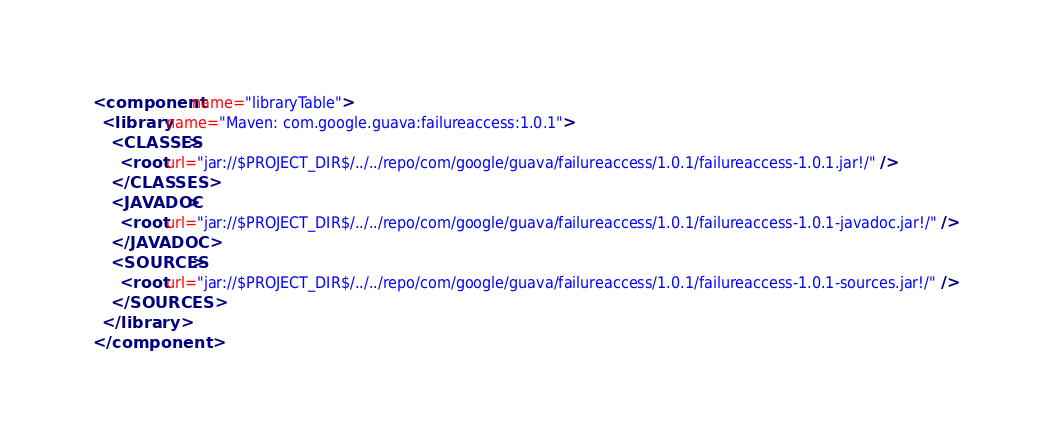Convert code to text. <code><loc_0><loc_0><loc_500><loc_500><_XML_><component name="libraryTable">
  <library name="Maven: com.google.guava:failureaccess:1.0.1">
    <CLASSES>
      <root url="jar://$PROJECT_DIR$/../../repo/com/google/guava/failureaccess/1.0.1/failureaccess-1.0.1.jar!/" />
    </CLASSES>
    <JAVADOC>
      <root url="jar://$PROJECT_DIR$/../../repo/com/google/guava/failureaccess/1.0.1/failureaccess-1.0.1-javadoc.jar!/" />
    </JAVADOC>
    <SOURCES>
      <root url="jar://$PROJECT_DIR$/../../repo/com/google/guava/failureaccess/1.0.1/failureaccess-1.0.1-sources.jar!/" />
    </SOURCES>
  </library>
</component></code> 